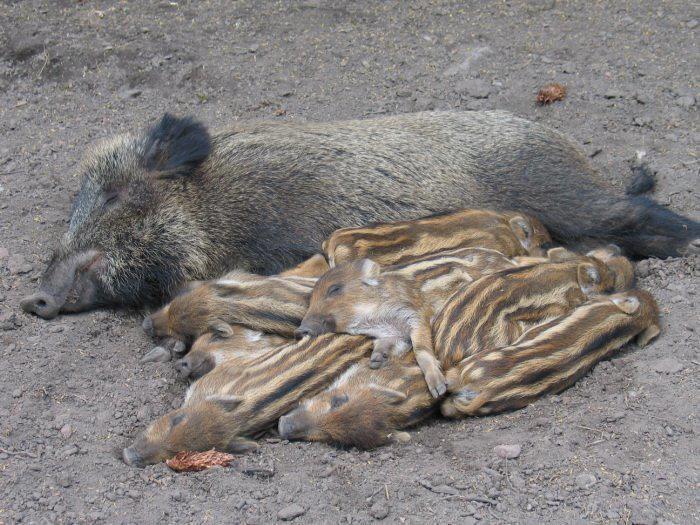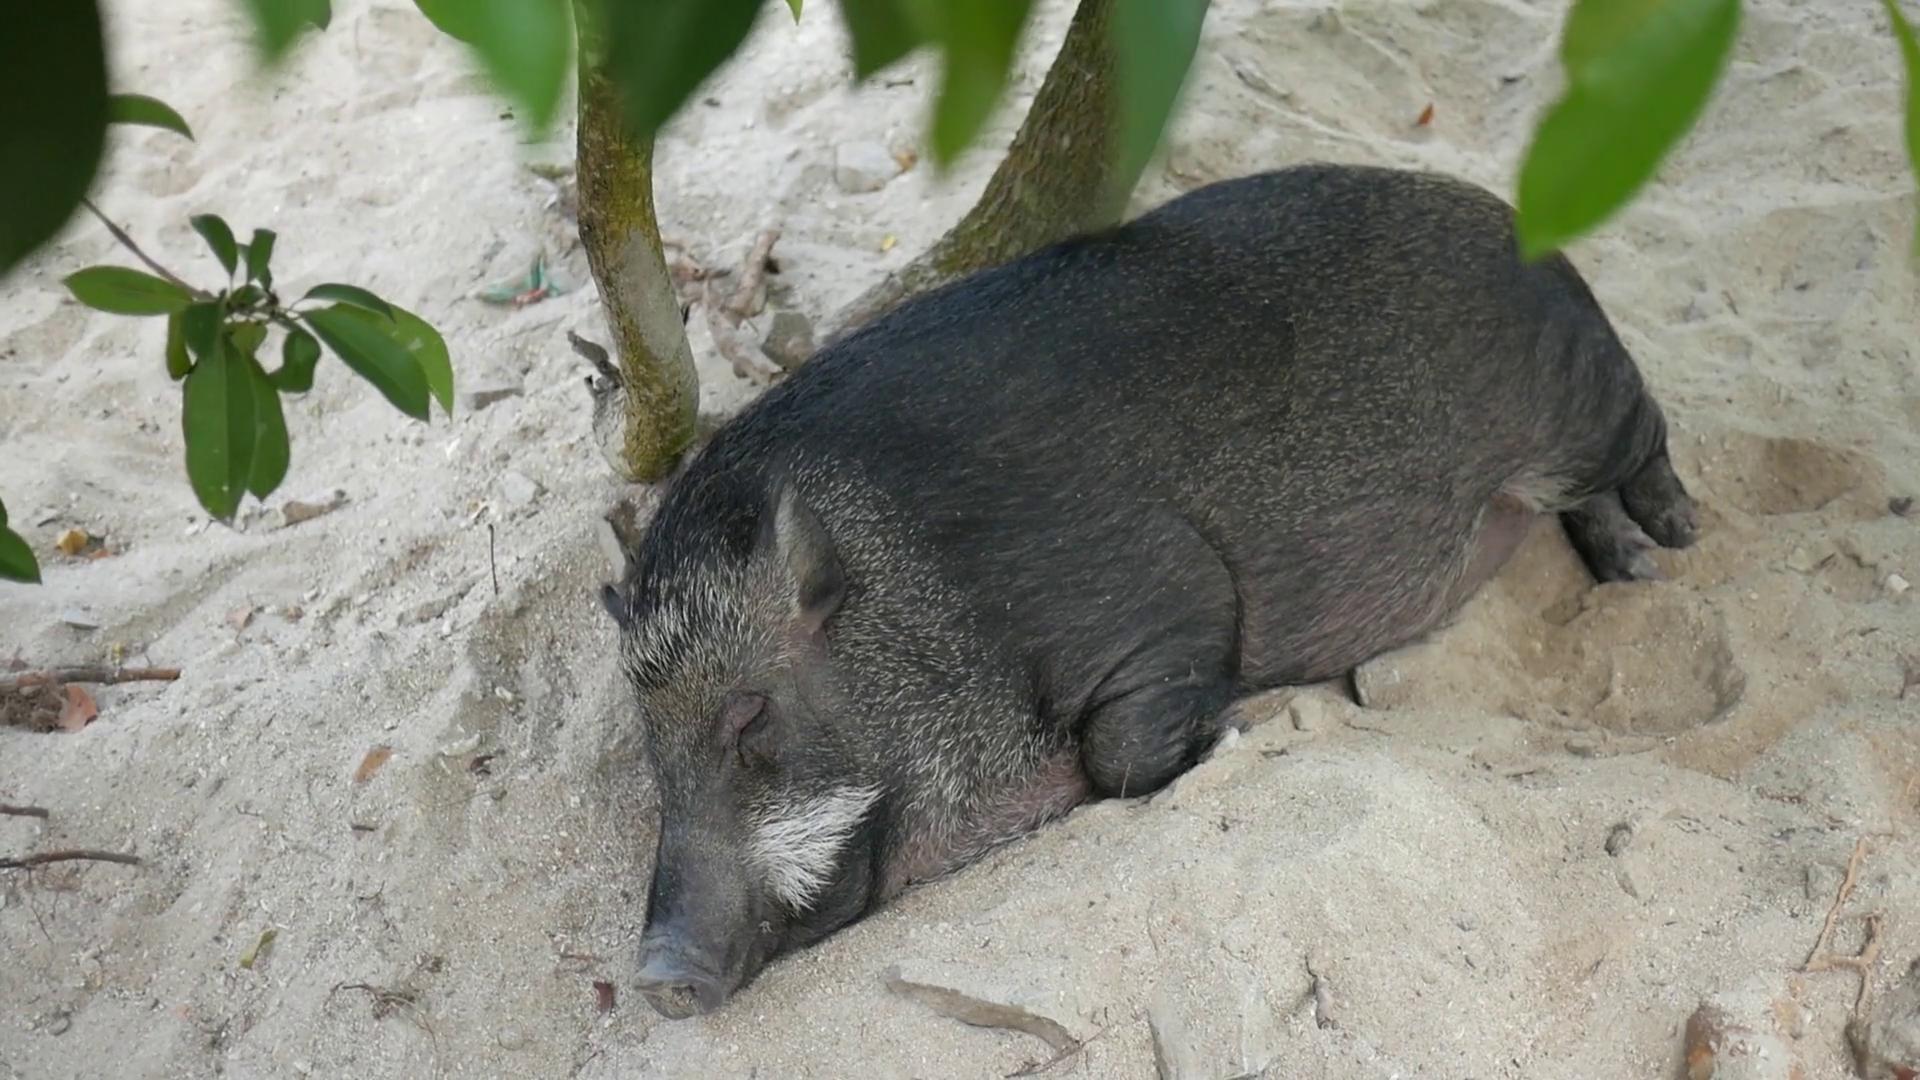The first image is the image on the left, the second image is the image on the right. Assess this claim about the two images: "All pigs are in sleeping poses, and at least one pig is a baby with distinctive stripes.". Correct or not? Answer yes or no. Yes. The first image is the image on the left, the second image is the image on the right. For the images displayed, is the sentence "There are two hogs in the pair of images." factually correct? Answer yes or no. No. 